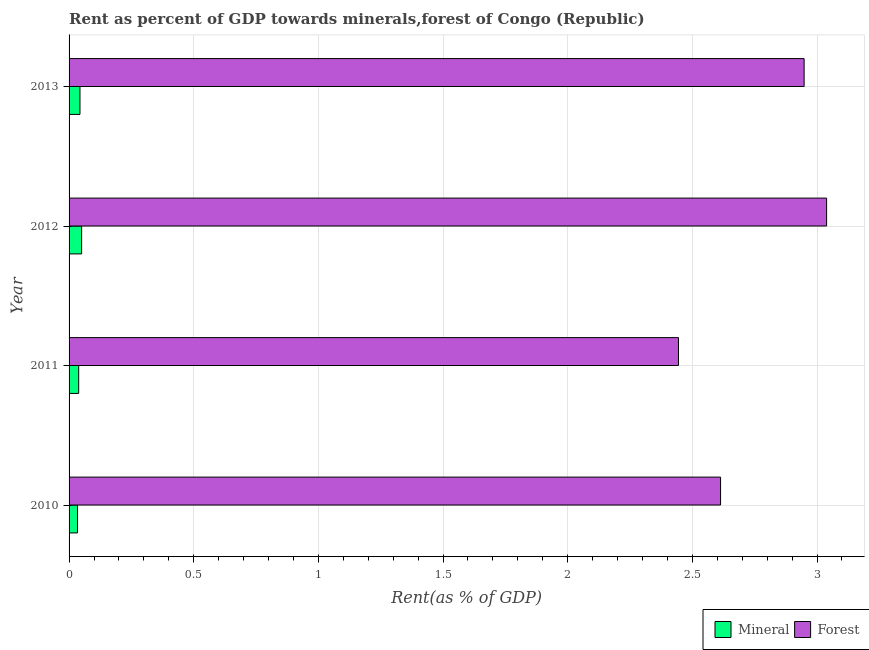How many different coloured bars are there?
Provide a succinct answer. 2. Are the number of bars per tick equal to the number of legend labels?
Offer a very short reply. Yes. How many bars are there on the 3rd tick from the top?
Your response must be concise. 2. How many bars are there on the 1st tick from the bottom?
Your response must be concise. 2. What is the label of the 3rd group of bars from the top?
Your answer should be very brief. 2011. In how many cases, is the number of bars for a given year not equal to the number of legend labels?
Offer a terse response. 0. What is the mineral rent in 2011?
Provide a succinct answer. 0.04. Across all years, what is the maximum mineral rent?
Provide a short and direct response. 0.05. Across all years, what is the minimum forest rent?
Your answer should be compact. 2.44. What is the total forest rent in the graph?
Your response must be concise. 11.04. What is the difference between the mineral rent in 2011 and that in 2012?
Offer a very short reply. -0.01. What is the difference between the forest rent in 2011 and the mineral rent in 2010?
Offer a terse response. 2.41. What is the average forest rent per year?
Give a very brief answer. 2.76. In the year 2011, what is the difference between the mineral rent and forest rent?
Give a very brief answer. -2.41. What is the ratio of the forest rent in 2010 to that in 2011?
Your answer should be very brief. 1.07. Is the forest rent in 2010 less than that in 2011?
Your answer should be very brief. No. What is the difference between the highest and the second highest forest rent?
Your answer should be very brief. 0.09. What is the difference between the highest and the lowest mineral rent?
Offer a very short reply. 0.02. What does the 1st bar from the top in 2010 represents?
Ensure brevity in your answer.  Forest. What does the 2nd bar from the bottom in 2012 represents?
Ensure brevity in your answer.  Forest. How many bars are there?
Provide a succinct answer. 8. Does the graph contain any zero values?
Keep it short and to the point. No. Does the graph contain grids?
Make the answer very short. Yes. How many legend labels are there?
Your answer should be compact. 2. What is the title of the graph?
Offer a terse response. Rent as percent of GDP towards minerals,forest of Congo (Republic). What is the label or title of the X-axis?
Your answer should be compact. Rent(as % of GDP). What is the Rent(as % of GDP) of Mineral in 2010?
Offer a very short reply. 0.03. What is the Rent(as % of GDP) of Forest in 2010?
Keep it short and to the point. 2.61. What is the Rent(as % of GDP) in Mineral in 2011?
Your response must be concise. 0.04. What is the Rent(as % of GDP) of Forest in 2011?
Provide a succinct answer. 2.44. What is the Rent(as % of GDP) in Mineral in 2012?
Your answer should be very brief. 0.05. What is the Rent(as % of GDP) in Forest in 2012?
Your answer should be very brief. 3.04. What is the Rent(as % of GDP) of Mineral in 2013?
Offer a very short reply. 0.04. What is the Rent(as % of GDP) in Forest in 2013?
Provide a short and direct response. 2.95. Across all years, what is the maximum Rent(as % of GDP) in Mineral?
Your response must be concise. 0.05. Across all years, what is the maximum Rent(as % of GDP) in Forest?
Ensure brevity in your answer.  3.04. Across all years, what is the minimum Rent(as % of GDP) of Mineral?
Your response must be concise. 0.03. Across all years, what is the minimum Rent(as % of GDP) of Forest?
Your answer should be very brief. 2.44. What is the total Rent(as % of GDP) in Mineral in the graph?
Offer a very short reply. 0.17. What is the total Rent(as % of GDP) of Forest in the graph?
Your answer should be very brief. 11.04. What is the difference between the Rent(as % of GDP) in Mineral in 2010 and that in 2011?
Make the answer very short. -0. What is the difference between the Rent(as % of GDP) in Forest in 2010 and that in 2011?
Make the answer very short. 0.17. What is the difference between the Rent(as % of GDP) in Mineral in 2010 and that in 2012?
Give a very brief answer. -0.02. What is the difference between the Rent(as % of GDP) of Forest in 2010 and that in 2012?
Keep it short and to the point. -0.43. What is the difference between the Rent(as % of GDP) of Mineral in 2010 and that in 2013?
Keep it short and to the point. -0.01. What is the difference between the Rent(as % of GDP) of Forest in 2010 and that in 2013?
Keep it short and to the point. -0.34. What is the difference between the Rent(as % of GDP) in Mineral in 2011 and that in 2012?
Offer a very short reply. -0.01. What is the difference between the Rent(as % of GDP) of Forest in 2011 and that in 2012?
Your answer should be very brief. -0.59. What is the difference between the Rent(as % of GDP) in Mineral in 2011 and that in 2013?
Your answer should be compact. -0.01. What is the difference between the Rent(as % of GDP) of Forest in 2011 and that in 2013?
Ensure brevity in your answer.  -0.5. What is the difference between the Rent(as % of GDP) of Mineral in 2012 and that in 2013?
Provide a succinct answer. 0.01. What is the difference between the Rent(as % of GDP) in Forest in 2012 and that in 2013?
Make the answer very short. 0.09. What is the difference between the Rent(as % of GDP) of Mineral in 2010 and the Rent(as % of GDP) of Forest in 2011?
Offer a very short reply. -2.41. What is the difference between the Rent(as % of GDP) of Mineral in 2010 and the Rent(as % of GDP) of Forest in 2012?
Keep it short and to the point. -3. What is the difference between the Rent(as % of GDP) in Mineral in 2010 and the Rent(as % of GDP) in Forest in 2013?
Keep it short and to the point. -2.91. What is the difference between the Rent(as % of GDP) in Mineral in 2011 and the Rent(as % of GDP) in Forest in 2012?
Make the answer very short. -3. What is the difference between the Rent(as % of GDP) of Mineral in 2011 and the Rent(as % of GDP) of Forest in 2013?
Provide a succinct answer. -2.91. What is the difference between the Rent(as % of GDP) in Mineral in 2012 and the Rent(as % of GDP) in Forest in 2013?
Your answer should be compact. -2.9. What is the average Rent(as % of GDP) in Mineral per year?
Your answer should be very brief. 0.04. What is the average Rent(as % of GDP) of Forest per year?
Give a very brief answer. 2.76. In the year 2010, what is the difference between the Rent(as % of GDP) of Mineral and Rent(as % of GDP) of Forest?
Provide a succinct answer. -2.58. In the year 2011, what is the difference between the Rent(as % of GDP) in Mineral and Rent(as % of GDP) in Forest?
Ensure brevity in your answer.  -2.41. In the year 2012, what is the difference between the Rent(as % of GDP) in Mineral and Rent(as % of GDP) in Forest?
Make the answer very short. -2.99. In the year 2013, what is the difference between the Rent(as % of GDP) of Mineral and Rent(as % of GDP) of Forest?
Keep it short and to the point. -2.9. What is the ratio of the Rent(as % of GDP) of Mineral in 2010 to that in 2011?
Keep it short and to the point. 0.88. What is the ratio of the Rent(as % of GDP) in Forest in 2010 to that in 2011?
Your answer should be very brief. 1.07. What is the ratio of the Rent(as % of GDP) in Mineral in 2010 to that in 2012?
Your answer should be compact. 0.67. What is the ratio of the Rent(as % of GDP) of Forest in 2010 to that in 2012?
Your answer should be very brief. 0.86. What is the ratio of the Rent(as % of GDP) of Mineral in 2010 to that in 2013?
Ensure brevity in your answer.  0.78. What is the ratio of the Rent(as % of GDP) of Forest in 2010 to that in 2013?
Offer a terse response. 0.89. What is the ratio of the Rent(as % of GDP) in Mineral in 2011 to that in 2012?
Give a very brief answer. 0.77. What is the ratio of the Rent(as % of GDP) in Forest in 2011 to that in 2012?
Keep it short and to the point. 0.8. What is the ratio of the Rent(as % of GDP) of Mineral in 2011 to that in 2013?
Your answer should be compact. 0.88. What is the ratio of the Rent(as % of GDP) in Forest in 2011 to that in 2013?
Provide a succinct answer. 0.83. What is the ratio of the Rent(as % of GDP) of Mineral in 2012 to that in 2013?
Give a very brief answer. 1.15. What is the ratio of the Rent(as % of GDP) of Forest in 2012 to that in 2013?
Your answer should be very brief. 1.03. What is the difference between the highest and the second highest Rent(as % of GDP) in Mineral?
Offer a very short reply. 0.01. What is the difference between the highest and the second highest Rent(as % of GDP) of Forest?
Offer a very short reply. 0.09. What is the difference between the highest and the lowest Rent(as % of GDP) in Mineral?
Your response must be concise. 0.02. What is the difference between the highest and the lowest Rent(as % of GDP) of Forest?
Offer a very short reply. 0.59. 